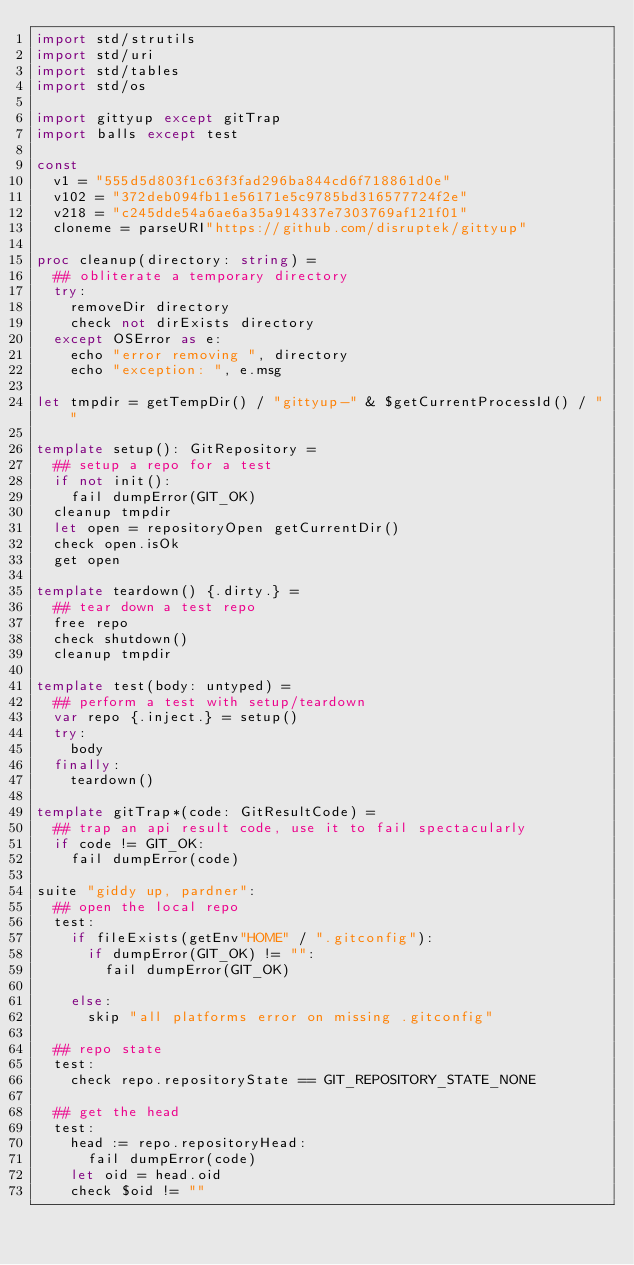<code> <loc_0><loc_0><loc_500><loc_500><_Nim_>import std/strutils
import std/uri
import std/tables
import std/os

import gittyup except gitTrap
import balls except test

const
  v1 = "555d5d803f1c63f3fad296ba844cd6f718861d0e"
  v102 = "372deb094fb11e56171e5c9785bd316577724f2e"
  v218 = "c245dde54a6ae6a35a914337e7303769af121f01"
  cloneme = parseURI"https://github.com/disruptek/gittyup"

proc cleanup(directory: string) =
  ## obliterate a temporary directory
  try:
    removeDir directory
    check not dirExists directory
  except OSError as e:
    echo "error removing ", directory
    echo "exception: ", e.msg

let tmpdir = getTempDir() / "gittyup-" & $getCurrentProcessId() / ""

template setup(): GitRepository =
  ## setup a repo for a test
  if not init():
    fail dumpError(GIT_OK)
  cleanup tmpdir
  let open = repositoryOpen getCurrentDir()
  check open.isOk
  get open

template teardown() {.dirty.} =
  ## tear down a test repo
  free repo
  check shutdown()
  cleanup tmpdir

template test(body: untyped) =
  ## perform a test with setup/teardown
  var repo {.inject.} = setup()
  try:
    body
  finally:
    teardown()

template gitTrap*(code: GitResultCode) =
  ## trap an api result code, use it to fail spectacularly
  if code != GIT_OK:
    fail dumpError(code)

suite "giddy up, pardner":
  ## open the local repo
  test:
    if fileExists(getEnv"HOME" / ".gitconfig"):
      if dumpError(GIT_OK) != "":
        fail dumpError(GIT_OK)

    else:
      skip "all platforms error on missing .gitconfig"

  ## repo state
  test:
    check repo.repositoryState == GIT_REPOSITORY_STATE_NONE

  ## get the head
  test:
    head := repo.repositoryHead:
      fail dumpError(code)
    let oid = head.oid
    check $oid != ""
</code> 